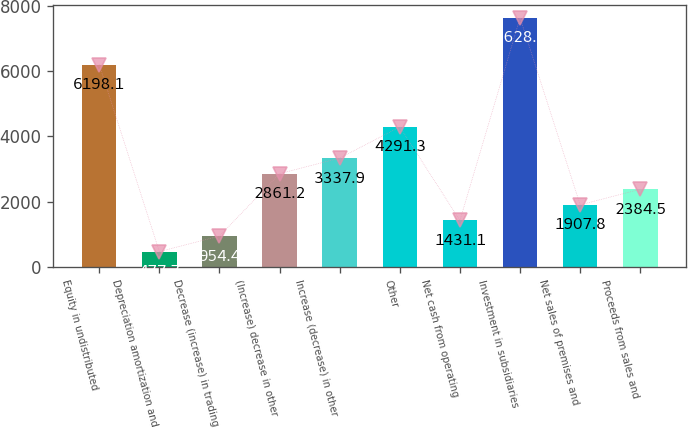<chart> <loc_0><loc_0><loc_500><loc_500><bar_chart><fcel>Equity in undistributed<fcel>Depreciation amortization and<fcel>Decrease (increase) in trading<fcel>(Increase) decrease in other<fcel>Increase (decrease) in other<fcel>Other<fcel>Net cash from operating<fcel>Investment in subsidiaries<fcel>Net sales of premises and<fcel>Proceeds from sales and<nl><fcel>6198.1<fcel>477.7<fcel>954.4<fcel>2861.2<fcel>3337.9<fcel>4291.3<fcel>1431.1<fcel>7628.2<fcel>1907.8<fcel>2384.5<nl></chart> 